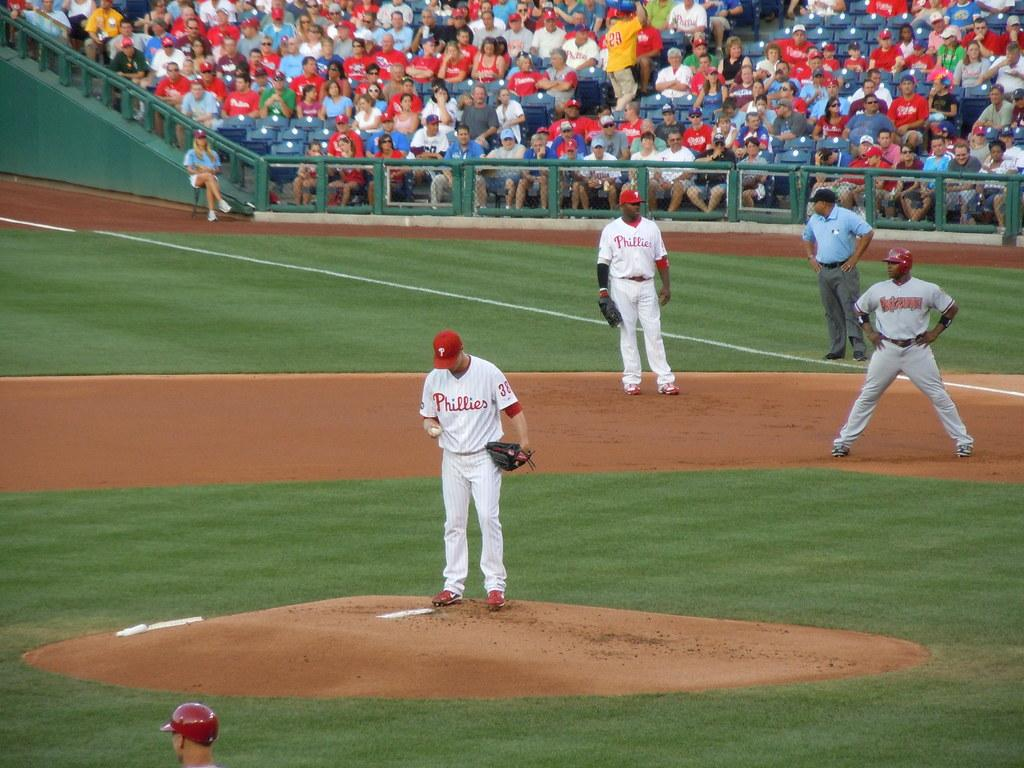<image>
Share a concise interpretation of the image provided. Pitcher #38 from the Phillies stands on the mound in a crowded stadium while a player from the opposing team prepares to run from the base. 